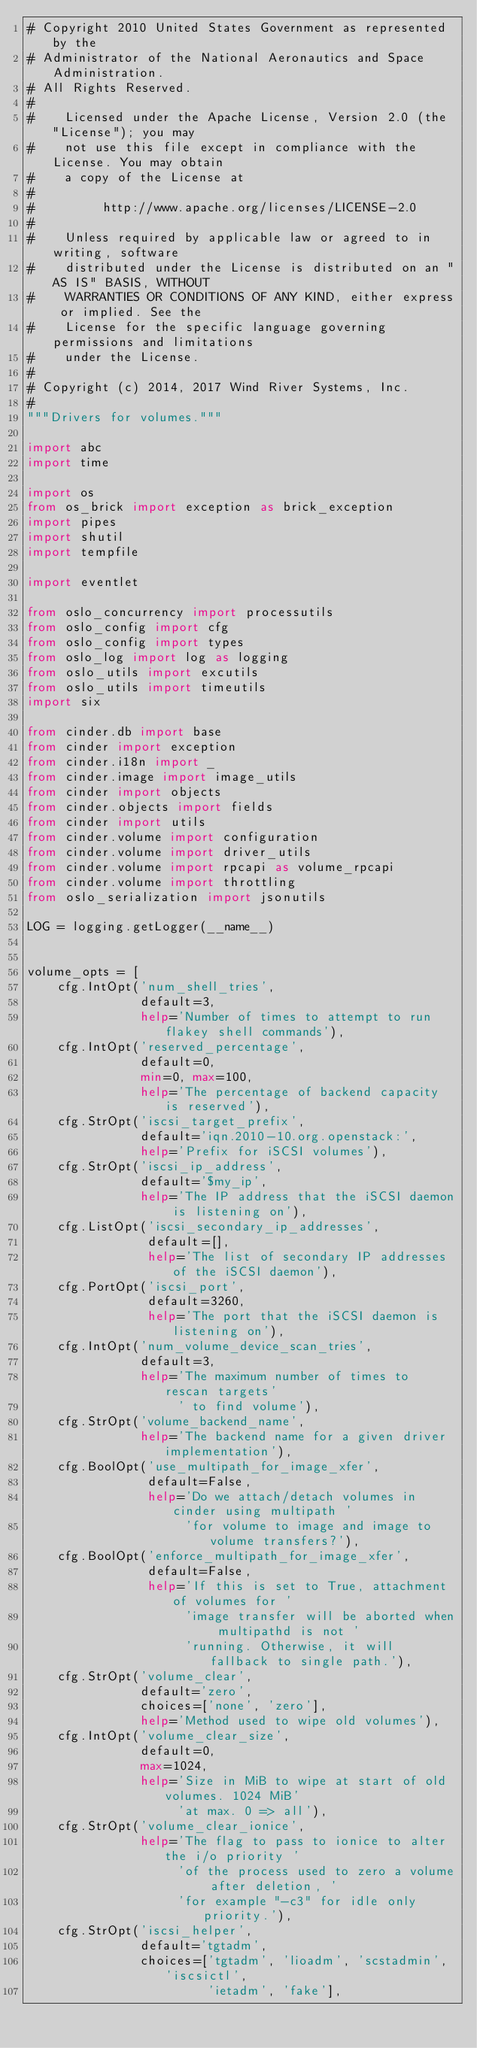<code> <loc_0><loc_0><loc_500><loc_500><_Python_># Copyright 2010 United States Government as represented by the
# Administrator of the National Aeronautics and Space Administration.
# All Rights Reserved.
#
#    Licensed under the Apache License, Version 2.0 (the "License"); you may
#    not use this file except in compliance with the License. You may obtain
#    a copy of the License at
#
#         http://www.apache.org/licenses/LICENSE-2.0
#
#    Unless required by applicable law or agreed to in writing, software
#    distributed under the License is distributed on an "AS IS" BASIS, WITHOUT
#    WARRANTIES OR CONDITIONS OF ANY KIND, either express or implied. See the
#    License for the specific language governing permissions and limitations
#    under the License.
#
# Copyright (c) 2014, 2017 Wind River Systems, Inc.
#
"""Drivers for volumes."""

import abc
import time

import os
from os_brick import exception as brick_exception
import pipes
import shutil
import tempfile

import eventlet

from oslo_concurrency import processutils
from oslo_config import cfg
from oslo_config import types
from oslo_log import log as logging
from oslo_utils import excutils
from oslo_utils import timeutils
import six

from cinder.db import base
from cinder import exception
from cinder.i18n import _
from cinder.image import image_utils
from cinder import objects
from cinder.objects import fields
from cinder import utils
from cinder.volume import configuration
from cinder.volume import driver_utils
from cinder.volume import rpcapi as volume_rpcapi
from cinder.volume import throttling
from oslo_serialization import jsonutils

LOG = logging.getLogger(__name__)


volume_opts = [
    cfg.IntOpt('num_shell_tries',
               default=3,
               help='Number of times to attempt to run flakey shell commands'),
    cfg.IntOpt('reserved_percentage',
               default=0,
               min=0, max=100,
               help='The percentage of backend capacity is reserved'),
    cfg.StrOpt('iscsi_target_prefix',
               default='iqn.2010-10.org.openstack:',
               help='Prefix for iSCSI volumes'),
    cfg.StrOpt('iscsi_ip_address',
               default='$my_ip',
               help='The IP address that the iSCSI daemon is listening on'),
    cfg.ListOpt('iscsi_secondary_ip_addresses',
                default=[],
                help='The list of secondary IP addresses of the iSCSI daemon'),
    cfg.PortOpt('iscsi_port',
                default=3260,
                help='The port that the iSCSI daemon is listening on'),
    cfg.IntOpt('num_volume_device_scan_tries',
               default=3,
               help='The maximum number of times to rescan targets'
                    ' to find volume'),
    cfg.StrOpt('volume_backend_name',
               help='The backend name for a given driver implementation'),
    cfg.BoolOpt('use_multipath_for_image_xfer',
                default=False,
                help='Do we attach/detach volumes in cinder using multipath '
                     'for volume to image and image to volume transfers?'),
    cfg.BoolOpt('enforce_multipath_for_image_xfer',
                default=False,
                help='If this is set to True, attachment of volumes for '
                     'image transfer will be aborted when multipathd is not '
                     'running. Otherwise, it will fallback to single path.'),
    cfg.StrOpt('volume_clear',
               default='zero',
               choices=['none', 'zero'],
               help='Method used to wipe old volumes'),
    cfg.IntOpt('volume_clear_size',
               default=0,
               max=1024,
               help='Size in MiB to wipe at start of old volumes. 1024 MiB'
                    'at max. 0 => all'),
    cfg.StrOpt('volume_clear_ionice',
               help='The flag to pass to ionice to alter the i/o priority '
                    'of the process used to zero a volume after deletion, '
                    'for example "-c3" for idle only priority.'),
    cfg.StrOpt('iscsi_helper',
               default='tgtadm',
               choices=['tgtadm', 'lioadm', 'scstadmin', 'iscsictl',
                        'ietadm', 'fake'],</code> 